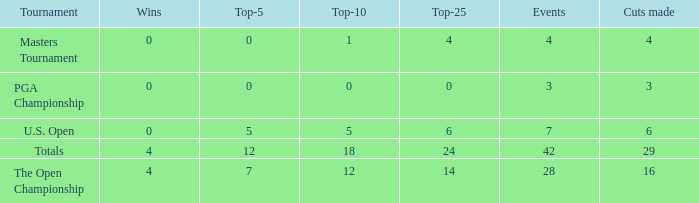What is the event average for a top-25 smaller than 0? None. 